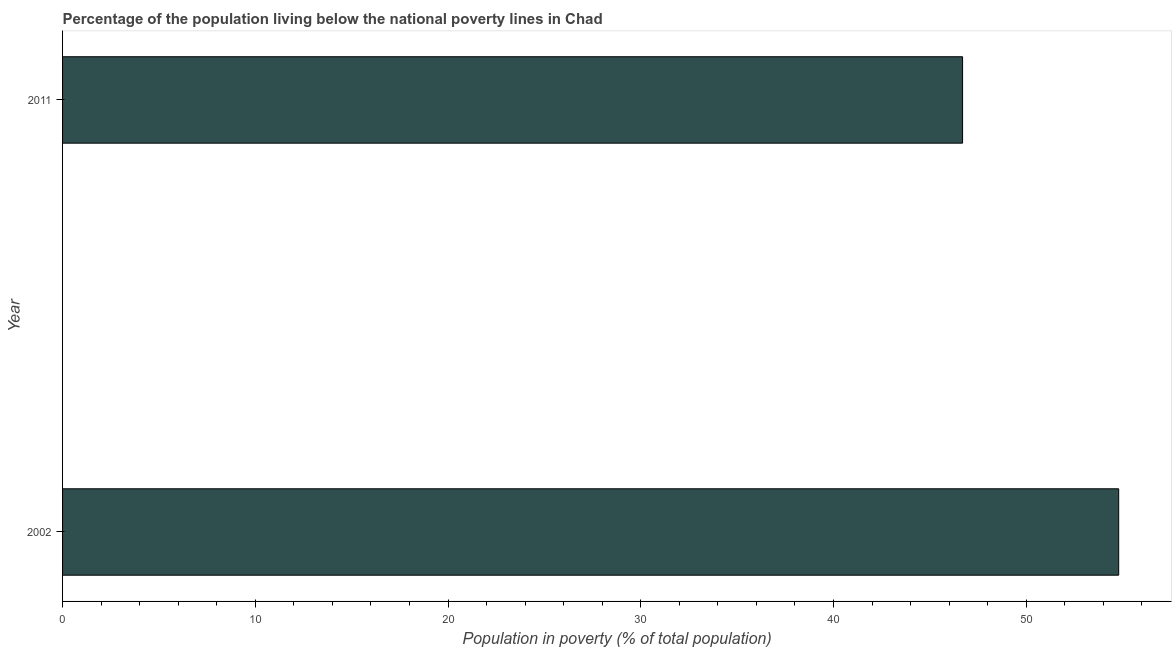Does the graph contain any zero values?
Provide a succinct answer. No. What is the title of the graph?
Give a very brief answer. Percentage of the population living below the national poverty lines in Chad. What is the label or title of the X-axis?
Offer a terse response. Population in poverty (% of total population). What is the percentage of population living below poverty line in 2011?
Your answer should be very brief. 46.7. Across all years, what is the maximum percentage of population living below poverty line?
Ensure brevity in your answer.  54.8. Across all years, what is the minimum percentage of population living below poverty line?
Make the answer very short. 46.7. In which year was the percentage of population living below poverty line minimum?
Your answer should be compact. 2011. What is the sum of the percentage of population living below poverty line?
Provide a succinct answer. 101.5. What is the average percentage of population living below poverty line per year?
Your answer should be very brief. 50.75. What is the median percentage of population living below poverty line?
Ensure brevity in your answer.  50.75. Do a majority of the years between 2002 and 2011 (inclusive) have percentage of population living below poverty line greater than 50 %?
Your answer should be compact. No. What is the ratio of the percentage of population living below poverty line in 2002 to that in 2011?
Keep it short and to the point. 1.17. In how many years, is the percentage of population living below poverty line greater than the average percentage of population living below poverty line taken over all years?
Your response must be concise. 1. Are the values on the major ticks of X-axis written in scientific E-notation?
Ensure brevity in your answer.  No. What is the Population in poverty (% of total population) in 2002?
Offer a terse response. 54.8. What is the Population in poverty (% of total population) of 2011?
Offer a terse response. 46.7. What is the ratio of the Population in poverty (% of total population) in 2002 to that in 2011?
Give a very brief answer. 1.17. 